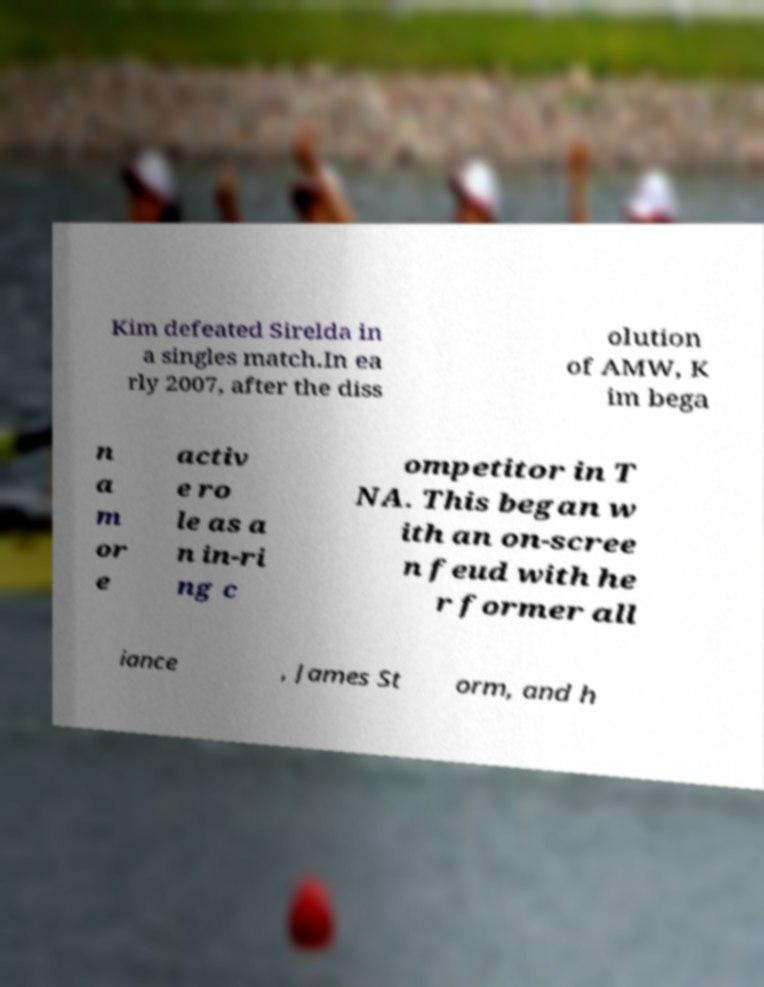There's text embedded in this image that I need extracted. Can you transcribe it verbatim? Kim defeated Sirelda in a singles match.In ea rly 2007, after the diss olution of AMW, K im bega n a m or e activ e ro le as a n in-ri ng c ompetitor in T NA. This began w ith an on-scree n feud with he r former all iance , James St orm, and h 